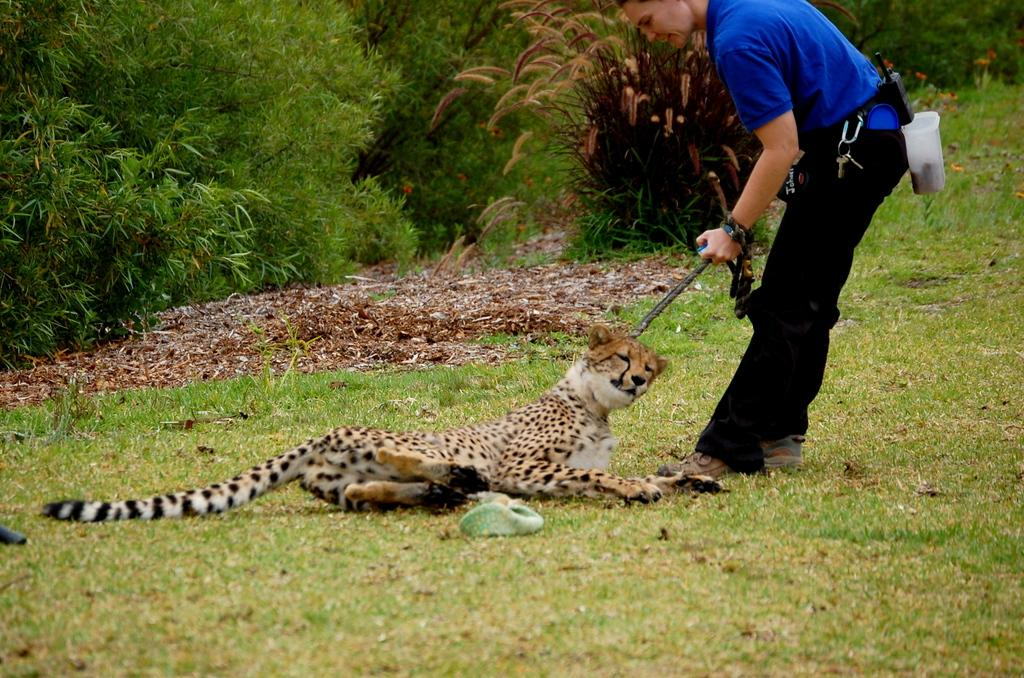What animal is present in the image? There is a Leopard in the image. What is the Leopard's location in the image? The Leopard is on the surface of the grass. What is the person in front of the Leopard doing? The person is holding a stick in his hand. What can be seen in the background of the image? There are trees visible in the background of the image. Where is the icicle located in the image? There is no icicle present in the image. What type of paint is being used by the Leopard in the image? The Leopard is an animal and does not use paint in the image. 